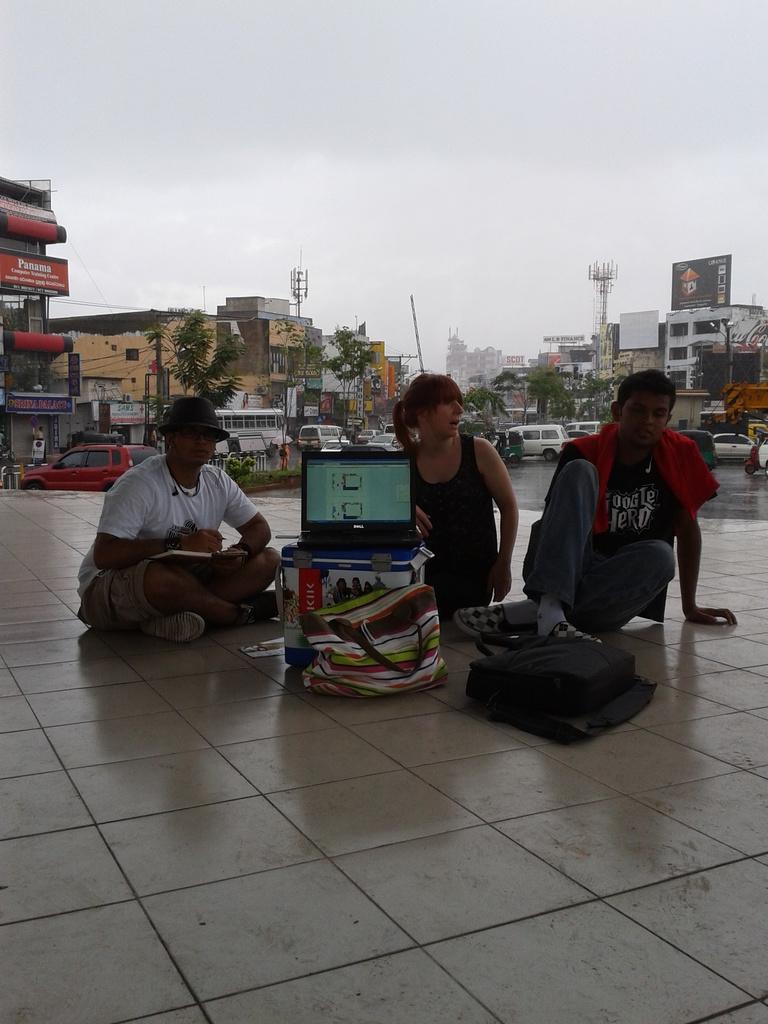Who or what can be seen in the image? There are people in the image. What type of structures are present in the image? There are buildings, towers, and a screen in the image. What natural elements can be seen in the image? There are trees and the sky visible in the image. What man-made objects are present in the image? There are vehicles and boards with text in the image. What is the ground like in the image? The ground is visible in the image with some objects. Can you see any veins in the image? There are no veins visible in the image, as it features people, buildings, trees, vehicles, towers, boards with text, the ground, and the sky. What type of fog can be seen in the image? There is no fog present in the image. 